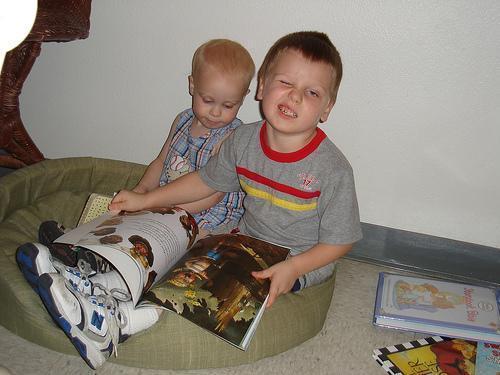How many children are there?
Give a very brief answer. 2. 